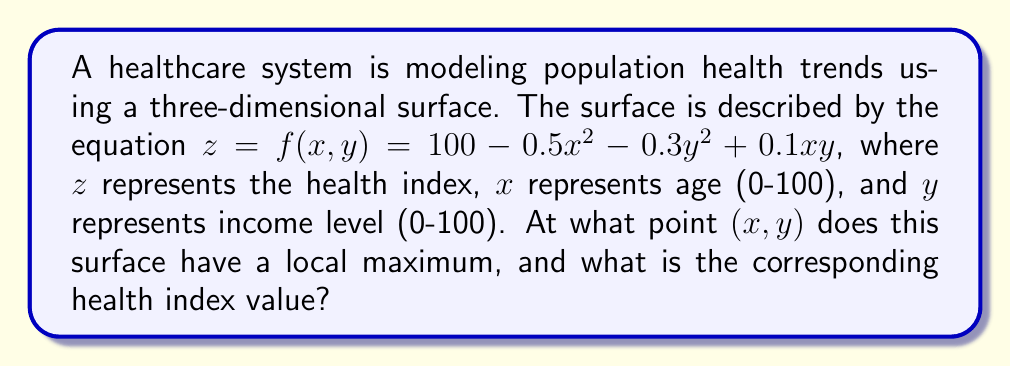Can you solve this math problem? To find the local maximum of the surface, we need to follow these steps:

1) Calculate the partial derivatives of $f(x,y)$ with respect to $x$ and $y$:

   $\frac{\partial f}{\partial x} = -x + 0.1y$
   $\frac{\partial f}{\partial y} = -0.6y + 0.1x$

2) Set both partial derivatives to zero to find the critical points:

   $-x + 0.1y = 0$  (Equation 1)
   $-0.6y + 0.1x = 0$  (Equation 2)

3) Solve this system of equations:
   From Equation 1: $x = 0.1y$
   Substitute this into Equation 2:
   $-0.6y + 0.1(0.1y) = 0$
   $-0.6y + 0.01y = 0$
   $-0.59y = 0$
   $y = 0$

   If $y = 0$, then from Equation 1: $x = 0$

4) Therefore, the critical point is at $(0,0)$

5) To confirm this is a local maximum, we need to check the second partial derivatives:

   $\frac{\partial^2 f}{\partial x^2} = -1$
   $\frac{\partial^2 f}{\partial y^2} = -0.6$
   $\frac{\partial^2 f}{\partial x\partial y} = \frac{\partial^2 f}{\partial y\partial x} = 0.1$

   The Hessian matrix at $(0,0)$ is:
   $H = \begin{bmatrix} -1 & 0.1 \\ 0.1 & -0.6 \end{bmatrix}$

   For a local maximum, the Hessian should be negative definite. We can check this by ensuring its determinant is positive and its trace is negative:

   $det(H) = (-1)(-0.6) - (0.1)(0.1) = 0.59 > 0$
   $trace(H) = -1 + (-0.6) = -1.6 < 0$

   Therefore, $(0,0)$ is indeed a local maximum.

6) Calculate the health index value at this point:

   $z = f(0,0) = 100 - 0.5(0)^2 - 0.3(0)^2 + 0.1(0)(0) = 100$

Thus, the local maximum occurs at $(0,0)$ with a health index value of 100.
Answer: $(0,0,100)$ 